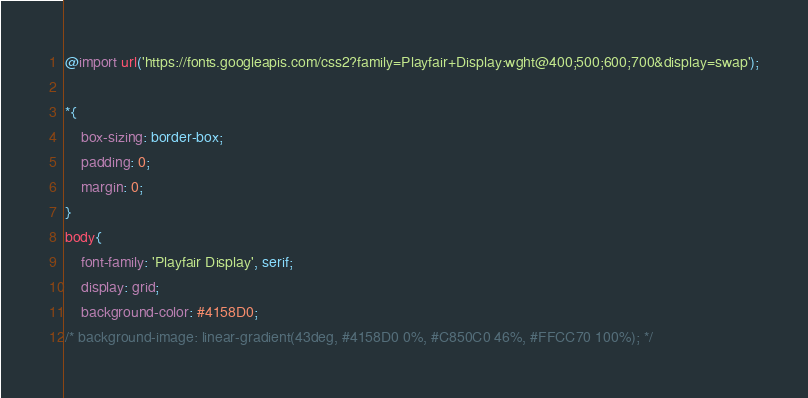<code> <loc_0><loc_0><loc_500><loc_500><_CSS_>
@import url('https://fonts.googleapis.com/css2?family=Playfair+Display:wght@400;500;600;700&display=swap');

*{
    box-sizing: border-box;
    padding: 0;
    margin: 0;
}
body{
    font-family: 'Playfair Display', serif;
    display: grid;
    background-color: #4158D0;
/* background-image: linear-gradient(43deg, #4158D0 0%, #C850C0 46%, #FFCC70 100%); */</code> 